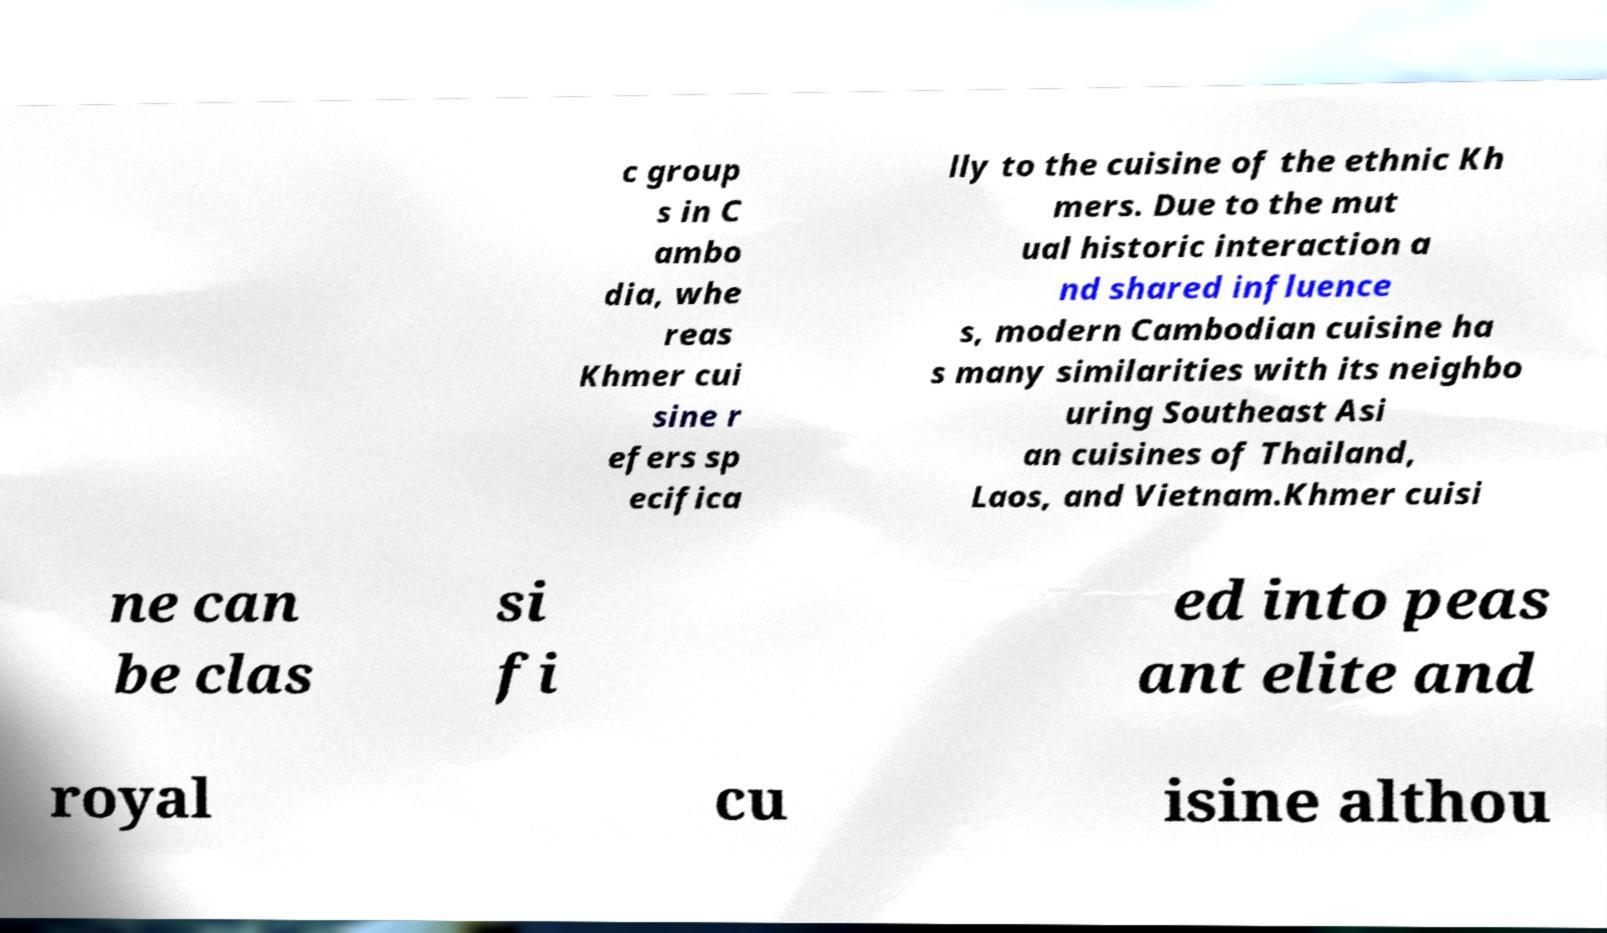Please identify and transcribe the text found in this image. c group s in C ambo dia, whe reas Khmer cui sine r efers sp ecifica lly to the cuisine of the ethnic Kh mers. Due to the mut ual historic interaction a nd shared influence s, modern Cambodian cuisine ha s many similarities with its neighbo uring Southeast Asi an cuisines of Thailand, Laos, and Vietnam.Khmer cuisi ne can be clas si fi ed into peas ant elite and royal cu isine althou 